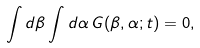<formula> <loc_0><loc_0><loc_500><loc_500>\int d \beta \int d \alpha \, G ( \beta , \alpha ; t ) = 0 ,</formula> 